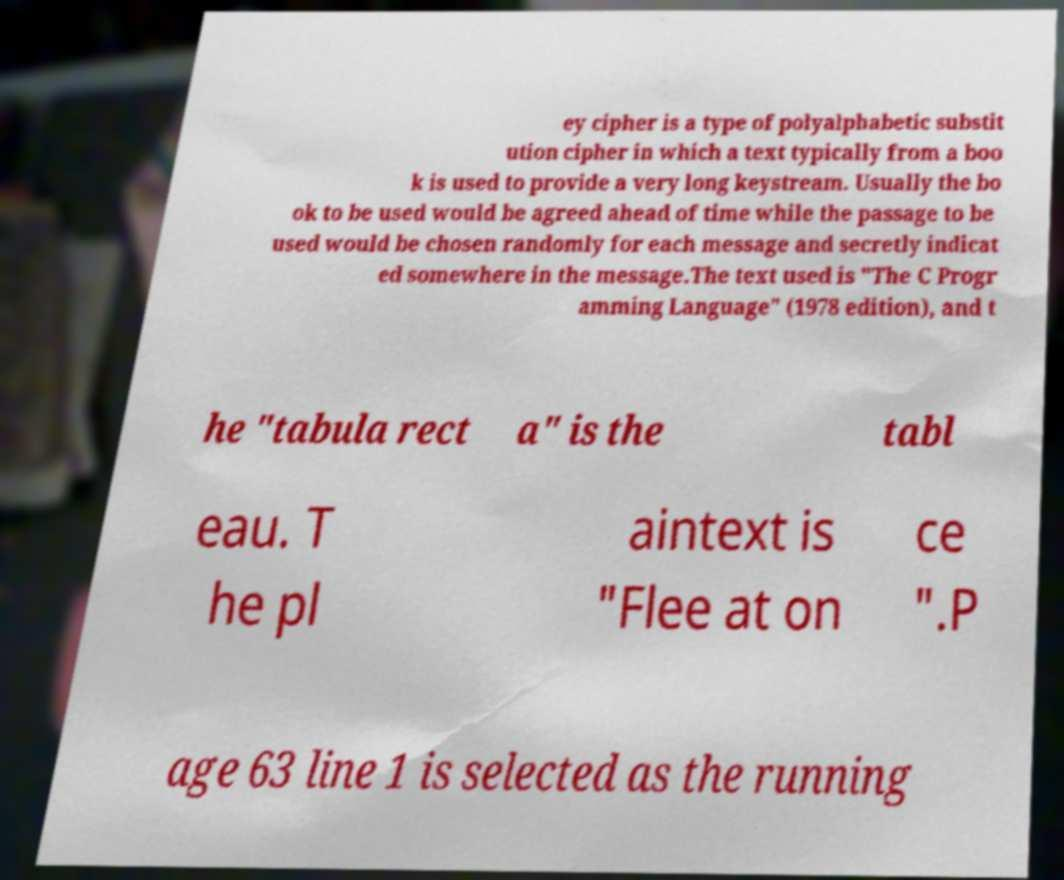For documentation purposes, I need the text within this image transcribed. Could you provide that? ey cipher is a type of polyalphabetic substit ution cipher in which a text typically from a boo k is used to provide a very long keystream. Usually the bo ok to be used would be agreed ahead of time while the passage to be used would be chosen randomly for each message and secretly indicat ed somewhere in the message.The text used is "The C Progr amming Language" (1978 edition), and t he "tabula rect a" is the tabl eau. T he pl aintext is "Flee at on ce ".P age 63 line 1 is selected as the running 